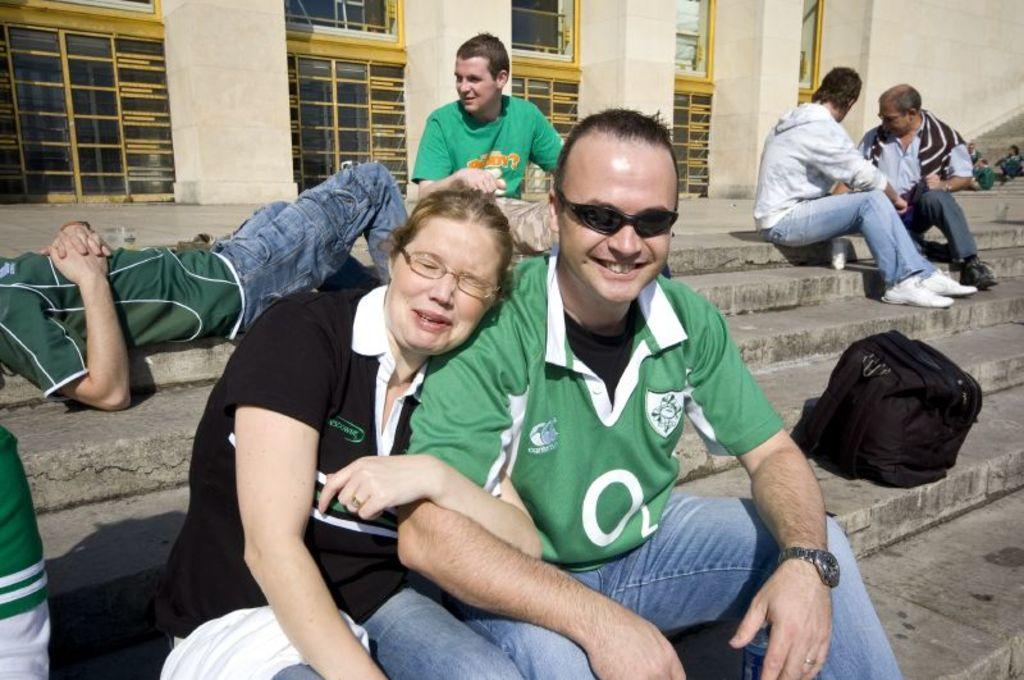What are the people in the image doing? The people in the image are sitting. Can you describe the position of the person on the left side of the image? There is a person lying on the left side of the image. What can be seen in the background of the image? There are windows visible in the background of the image. What type of brass instrument is being played by the band in the image? There is no brass instrument or band present in the image. 